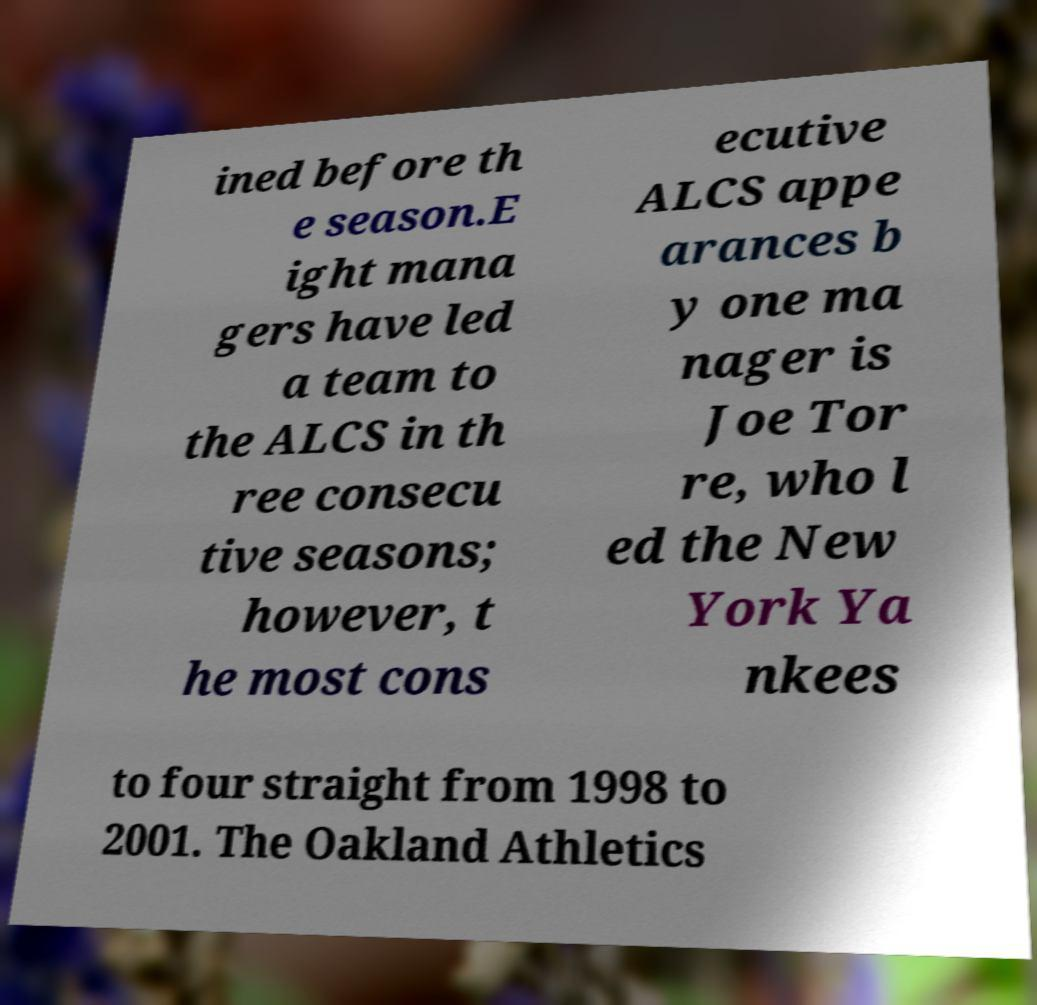Can you read and provide the text displayed in the image?This photo seems to have some interesting text. Can you extract and type it out for me? ined before th e season.E ight mana gers have led a team to the ALCS in th ree consecu tive seasons; however, t he most cons ecutive ALCS appe arances b y one ma nager is Joe Tor re, who l ed the New York Ya nkees to four straight from 1998 to 2001. The Oakland Athletics 